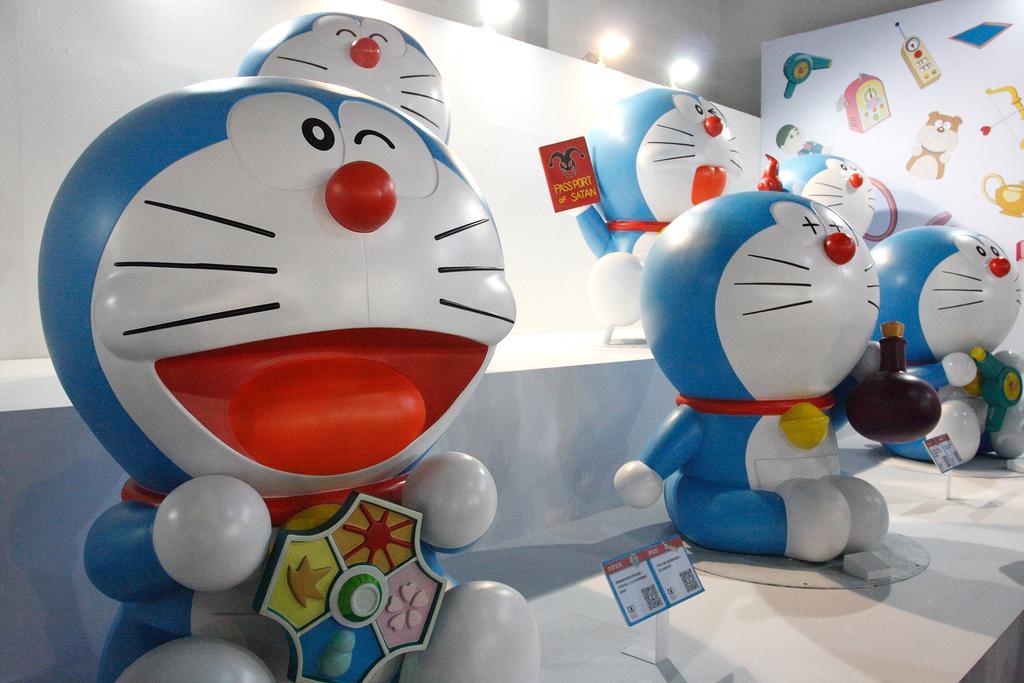Can you describe this image briefly? In the image there are few toys on the shelf with stickers on the right side wall with lights behind it. 